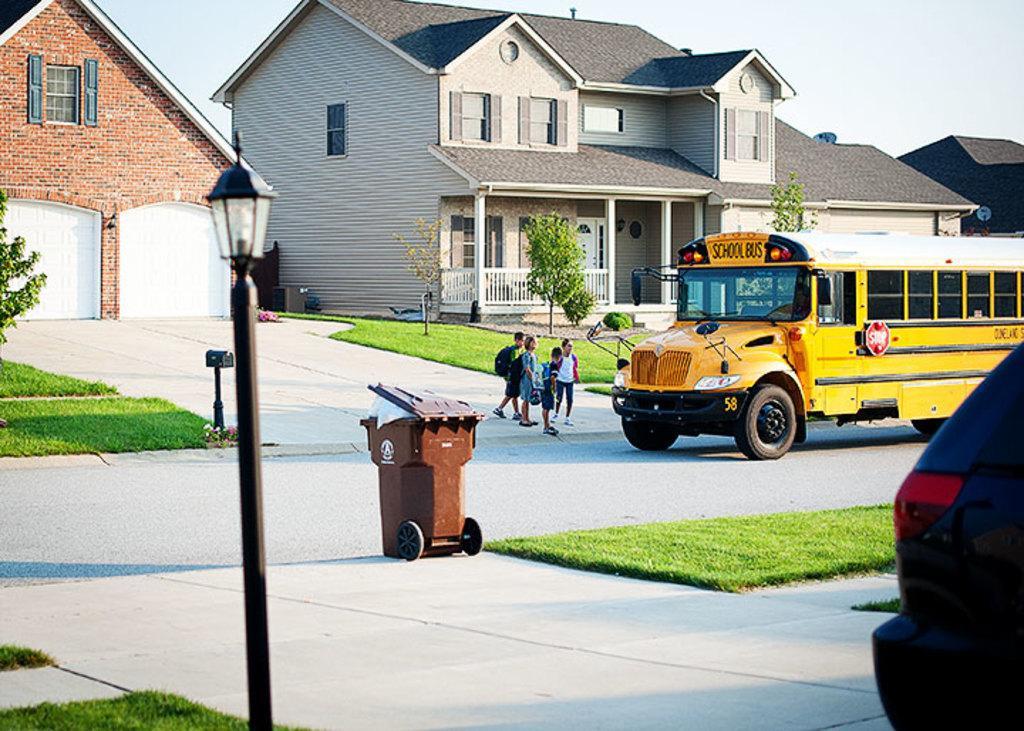Can you describe this image briefly? There is a road. On the road there is a school bus. Near to that there are children standing. There is a dustbin and a light pole. Also there are grass lawns and trees. In the back there are buildings with windows. And there is a building with pillars and railing. In the background there is sky. 